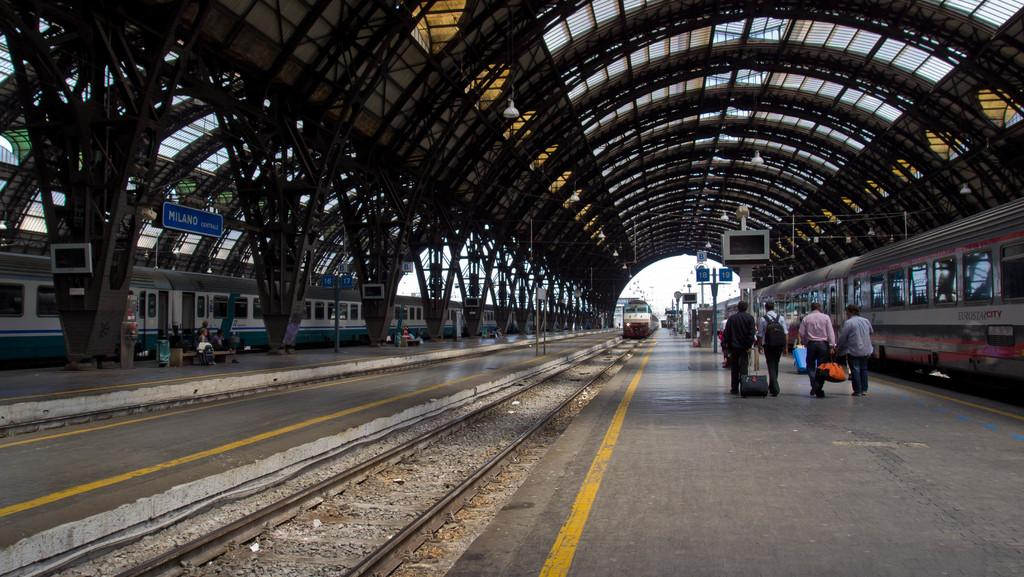What type of vehicles are on the tracks in the image? Trains are on the tracks in the image. Can you describe the people in the image? There are people in the image, and one person is wearing a bag. What objects are present in the image that provide information or guidance? There are sign boards in the image. What type of bone can be seen in the image? There is no bone present in the image. What sense is being utilized by the people in the image? The provided facts do not give information about the senses being utilized by the people in the image. --- 